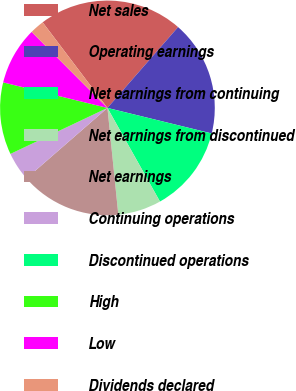<chart> <loc_0><loc_0><loc_500><loc_500><pie_chart><fcel>Net sales<fcel>Operating earnings<fcel>Net earnings from continuing<fcel>Net earnings from discontinued<fcel>Net earnings<fcel>Continuing operations<fcel>Discontinued operations<fcel>High<fcel>Low<fcel>Dividends declared<nl><fcel>21.74%<fcel>17.39%<fcel>13.04%<fcel>6.52%<fcel>15.22%<fcel>4.35%<fcel>0.0%<fcel>10.87%<fcel>8.7%<fcel>2.17%<nl></chart> 